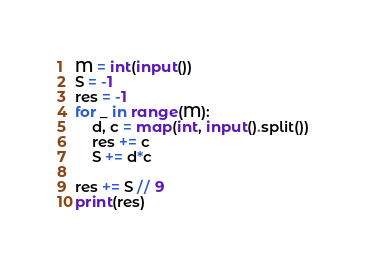<code> <loc_0><loc_0><loc_500><loc_500><_Python_>M = int(input())
S = -1
res = -1
for _ in range(M):
    d, c = map(int, input().split())
    res += c
    S += d*c

res += S // 9
print(res)</code> 